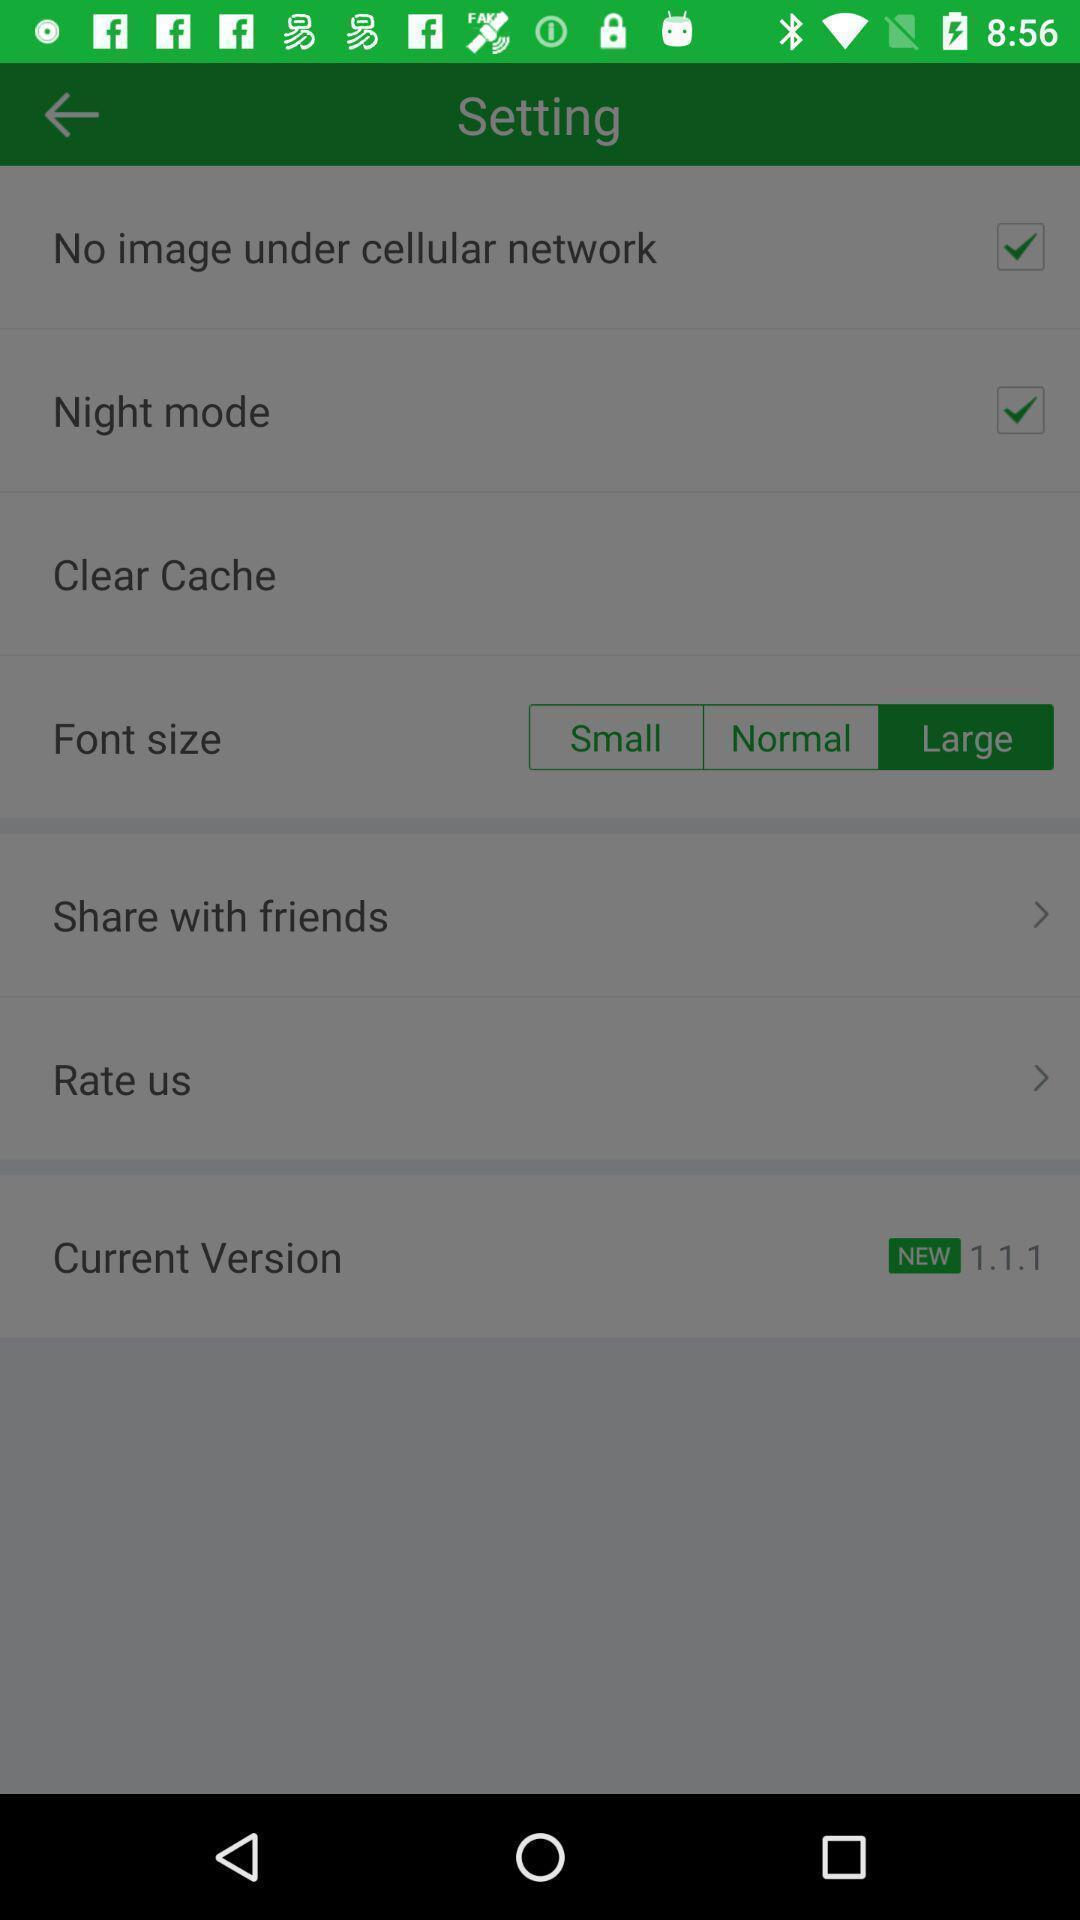Summarize the information in this screenshot. Settings page. 